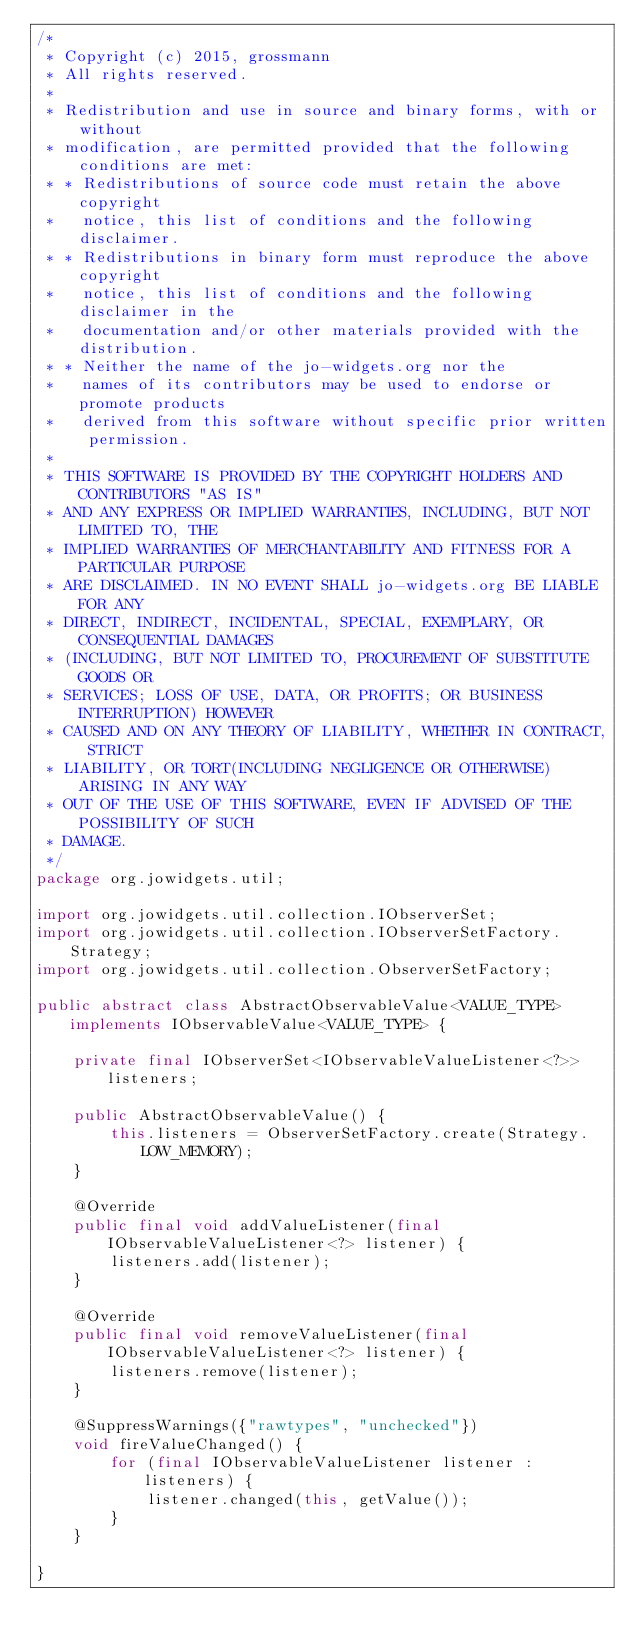<code> <loc_0><loc_0><loc_500><loc_500><_Java_>/*
 * Copyright (c) 2015, grossmann
 * All rights reserved.
 * 
 * Redistribution and use in source and binary forms, with or without
 * modification, are permitted provided that the following conditions are met:
 * * Redistributions of source code must retain the above copyright
 *   notice, this list of conditions and the following disclaimer.
 * * Redistributions in binary form must reproduce the above copyright
 *   notice, this list of conditions and the following disclaimer in the
 *   documentation and/or other materials provided with the distribution.
 * * Neither the name of the jo-widgets.org nor the
 *   names of its contributors may be used to endorse or promote products
 *   derived from this software without specific prior written permission.
 * 
 * THIS SOFTWARE IS PROVIDED BY THE COPYRIGHT HOLDERS AND CONTRIBUTORS "AS IS"
 * AND ANY EXPRESS OR IMPLIED WARRANTIES, INCLUDING, BUT NOT LIMITED TO, THE
 * IMPLIED WARRANTIES OF MERCHANTABILITY AND FITNESS FOR A PARTICULAR PURPOSE
 * ARE DISCLAIMED. IN NO EVENT SHALL jo-widgets.org BE LIABLE FOR ANY
 * DIRECT, INDIRECT, INCIDENTAL, SPECIAL, EXEMPLARY, OR CONSEQUENTIAL DAMAGES
 * (INCLUDING, BUT NOT LIMITED TO, PROCUREMENT OF SUBSTITUTE GOODS OR
 * SERVICES; LOSS OF USE, DATA, OR PROFITS; OR BUSINESS INTERRUPTION) HOWEVER
 * CAUSED AND ON ANY THEORY OF LIABILITY, WHETHER IN CONTRACT, STRICT
 * LIABILITY, OR TORT(INCLUDING NEGLIGENCE OR OTHERWISE) ARISING IN ANY WAY
 * OUT OF THE USE OF THIS SOFTWARE, EVEN IF ADVISED OF THE POSSIBILITY OF SUCH
 * DAMAGE.
 */
package org.jowidgets.util;

import org.jowidgets.util.collection.IObserverSet;
import org.jowidgets.util.collection.IObserverSetFactory.Strategy;
import org.jowidgets.util.collection.ObserverSetFactory;

public abstract class AbstractObservableValue<VALUE_TYPE> implements IObservableValue<VALUE_TYPE> {

    private final IObserverSet<IObservableValueListener<?>> listeners;

    public AbstractObservableValue() {
        this.listeners = ObserverSetFactory.create(Strategy.LOW_MEMORY);
    }

    @Override
    public final void addValueListener(final IObservableValueListener<?> listener) {
        listeners.add(listener);
    }

    @Override
    public final void removeValueListener(final IObservableValueListener<?> listener) {
        listeners.remove(listener);
    }

    @SuppressWarnings({"rawtypes", "unchecked"})
    void fireValueChanged() {
        for (final IObservableValueListener listener : listeners) {
            listener.changed(this, getValue());
        }
    }

}
</code> 